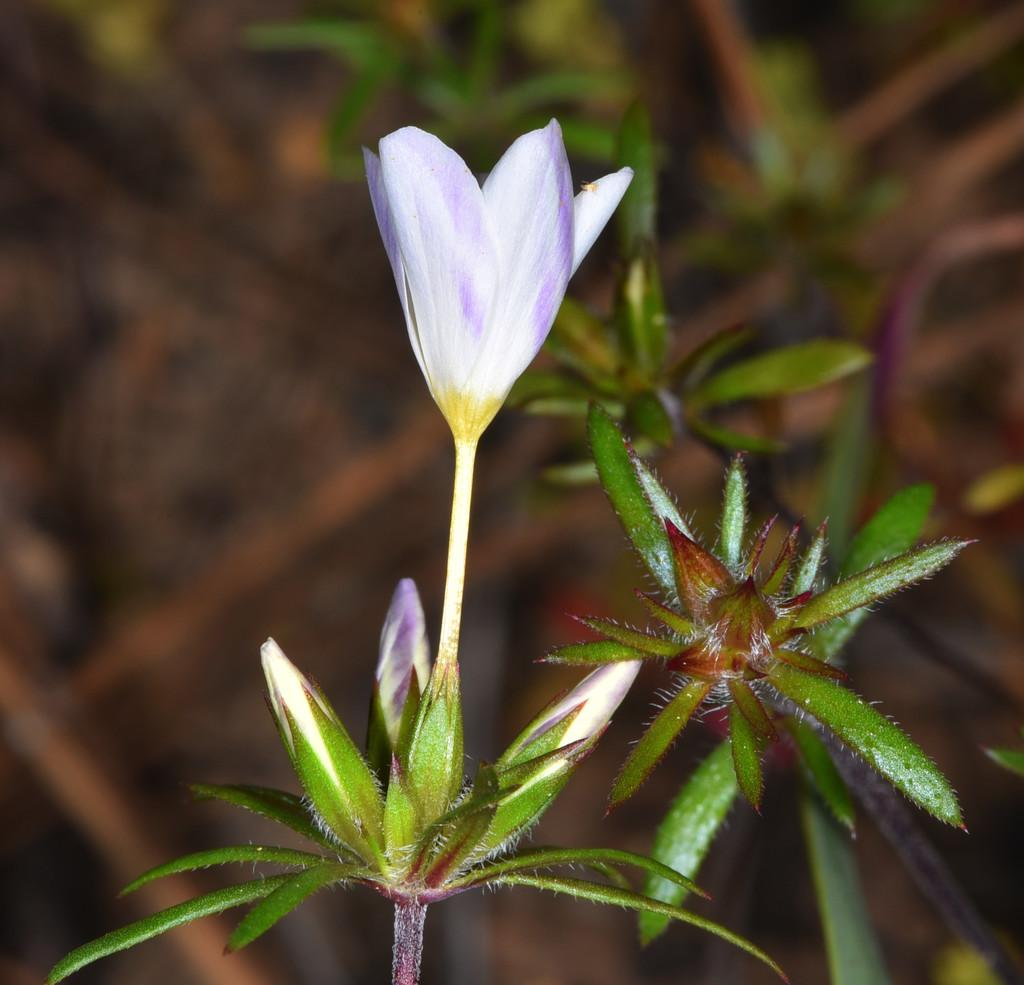What is the main subject in the center of the image? There is a flower in the center of the image. Are there any other plants visible in the image? Yes, there are other plants on the right side of the image. What type of protest is happening in the image? There is no protest present in the image; it features a flower and other plants. What kind of joke is being told by the flower in the image? There is no joke being told in the image; it is a still image of a flower and other plants. 